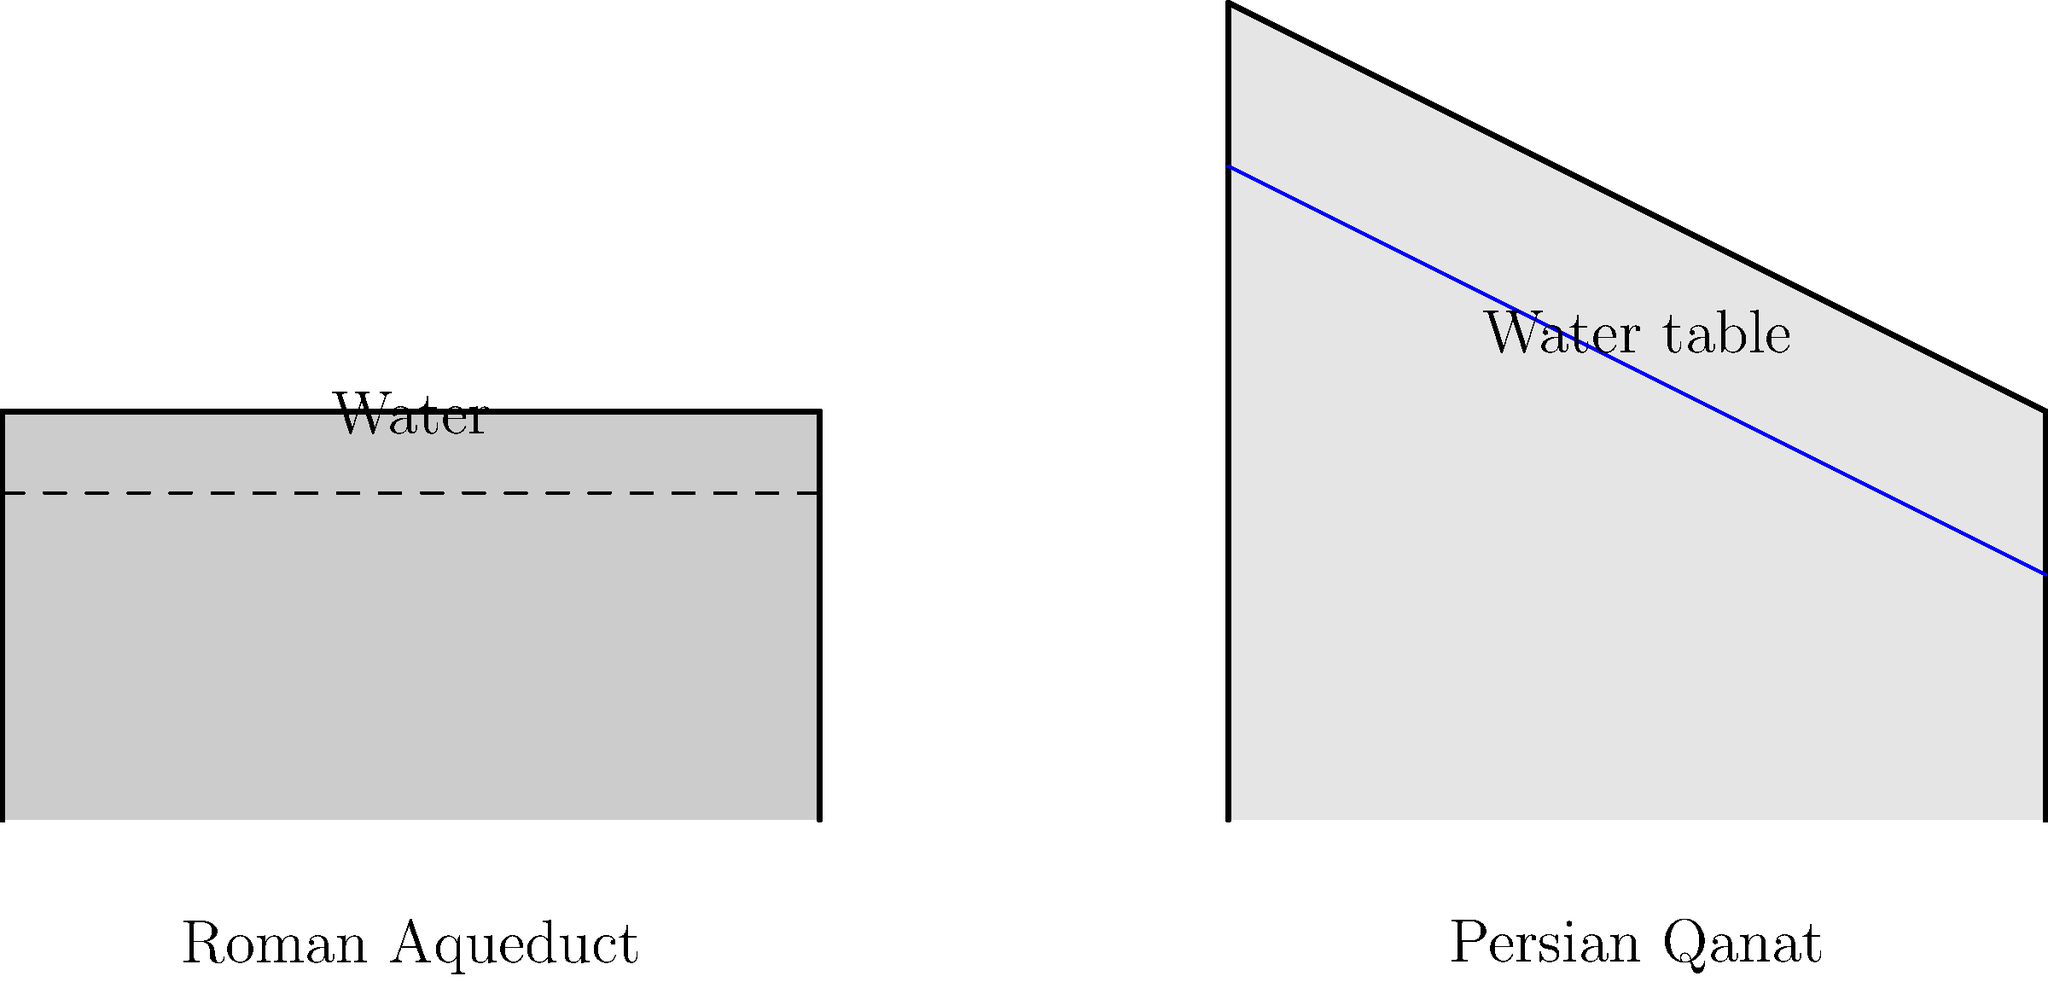Compare the cross-sections of the Roman aqueduct and Persian qanat shown in the diagram. Which system was more resilient to surface-level disruptions such as enemy attacks or natural disasters, and why? To answer this question, let's analyze both systems step-by-step:

1. Roman Aqueduct:
   - Built above ground or on raised structures
   - Water flows through an open channel at the top
   - Exposed to the surface environment

2. Persian Qanat:
   - Built underground
   - Water flows through a tunnel beneath the water table
   - Most of the structure is hidden beneath the surface

3. Resilience to surface-level disruptions:
   a) Enemy attacks:
      - Aqueducts: Easily visible and targetable
      - Qanats: Hidden underground, harder to locate and damage

   b) Natural disasters (e.g., earthquakes, floods):
      - Aqueducts: More susceptible to damage due to their elevated structure
      - Qanats: Less affected by surface events, protected by surrounding earth

4. Maintenance and repair:
   - Aqueducts: Easier to access for maintenance, but also easier for enemies to sabotage
   - Qanats: More challenging to maintain, but also more difficult for enemies to damage

5. Water source protection:
   - Aqueducts: Water is exposed to contamination and evaporation
   - Qanats: Water is protected underground, reducing contamination and evaporation risks

Considering these factors, the Persian qanat system was more resilient to surface-level disruptions. Its underground nature provided natural protection against both enemy attacks and many natural disasters, making it a more secure water supply system in times of conflict or environmental challenges.
Answer: Persian qanat, due to its underground construction 